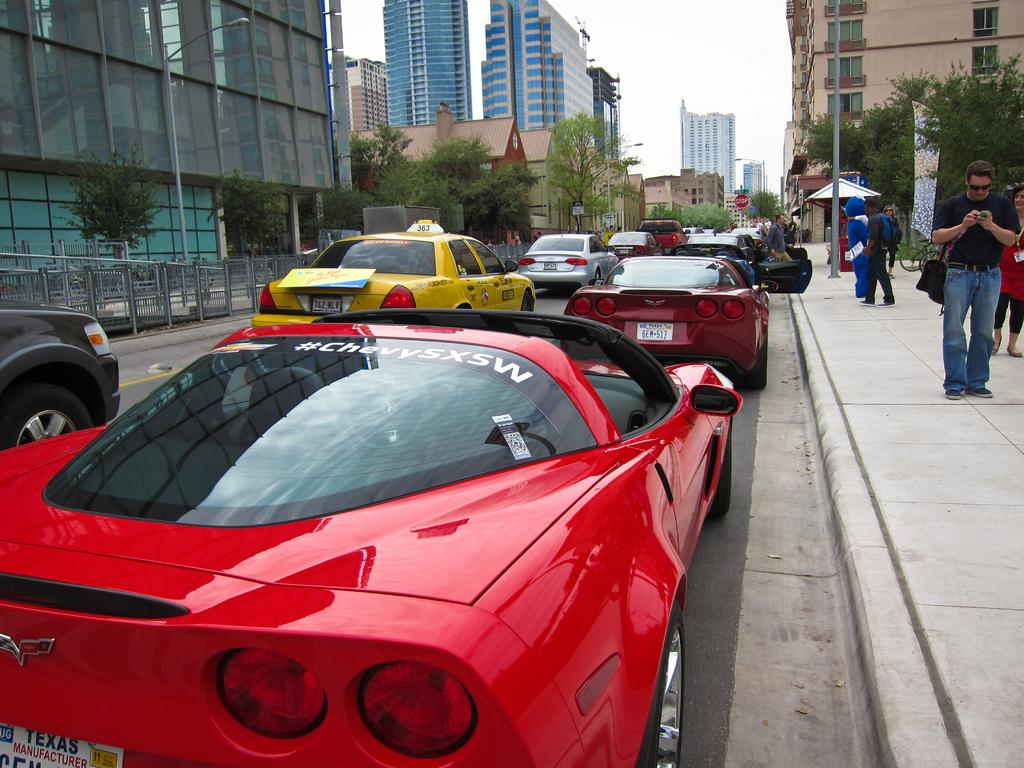<image>
Provide a brief description of the given image. A red corvette has #chevySXSW written on the back glass. 